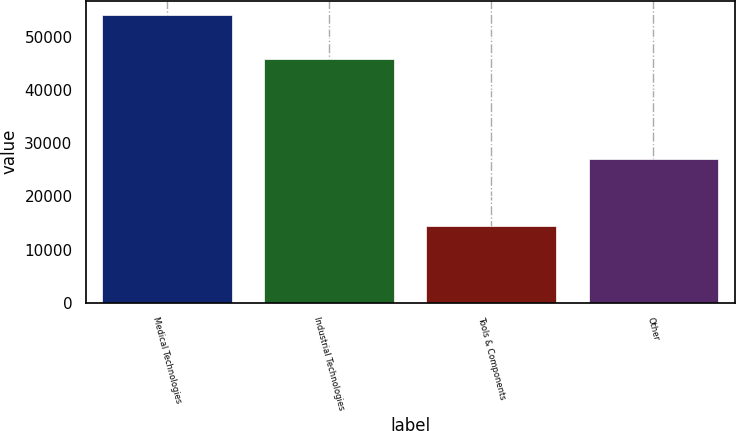Convert chart. <chart><loc_0><loc_0><loc_500><loc_500><bar_chart><fcel>Medical Technologies<fcel>Industrial Technologies<fcel>Tools & Components<fcel>Other<nl><fcel>54212<fcel>45868<fcel>14418<fcel>27145<nl></chart> 